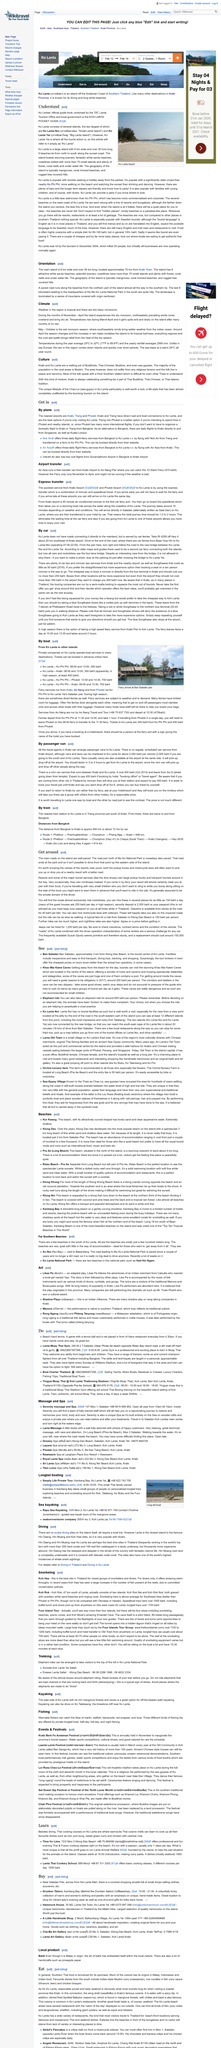Highlight a few significant elements in this photo. It is recommended that additional information be obtained from the sources of "Driving in Thailand" and "Driving in Ko Lanta" for a comprehensive understanding of the relevant details. The dry monsoon and the wet monsoon are the two basic monsoons. The main island is situated approximately 70km from Krabi Town and serves as the central point of the archipelago. Ko Lanta Noi is an island located off the Andaman Coast of Southern Thailand, and it is a part of the Lanta Island group. The dry monsoon occurs during the months of November to April. 